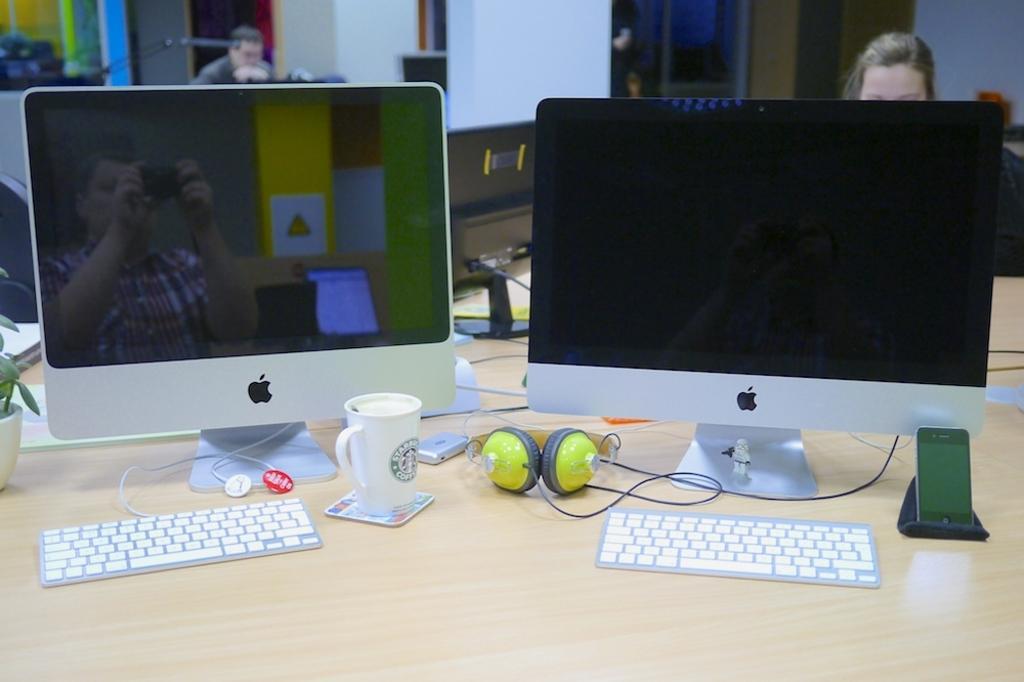Describe this image in one or two sentences. There is a table. On the table two computers, keyboards, glass, headsets and a mobile phone is there. Behind them some persons are sitting and building is over there. 